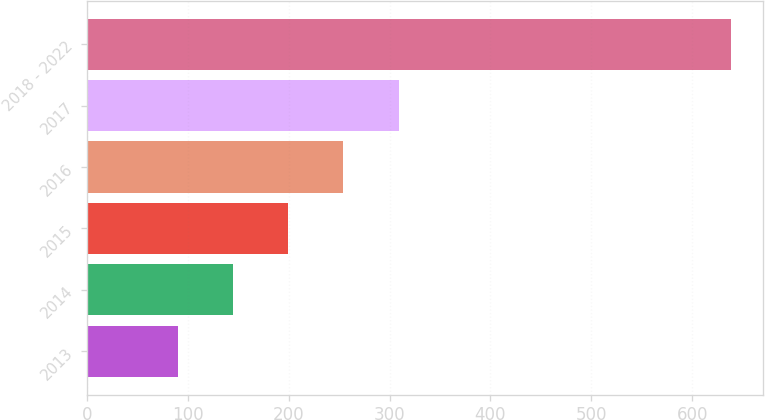<chart> <loc_0><loc_0><loc_500><loc_500><bar_chart><fcel>2013<fcel>2014<fcel>2015<fcel>2016<fcel>2017<fcel>2018 - 2022<nl><fcel>89.6<fcel>144.46<fcel>199.32<fcel>254.18<fcel>309.04<fcel>638.2<nl></chart> 